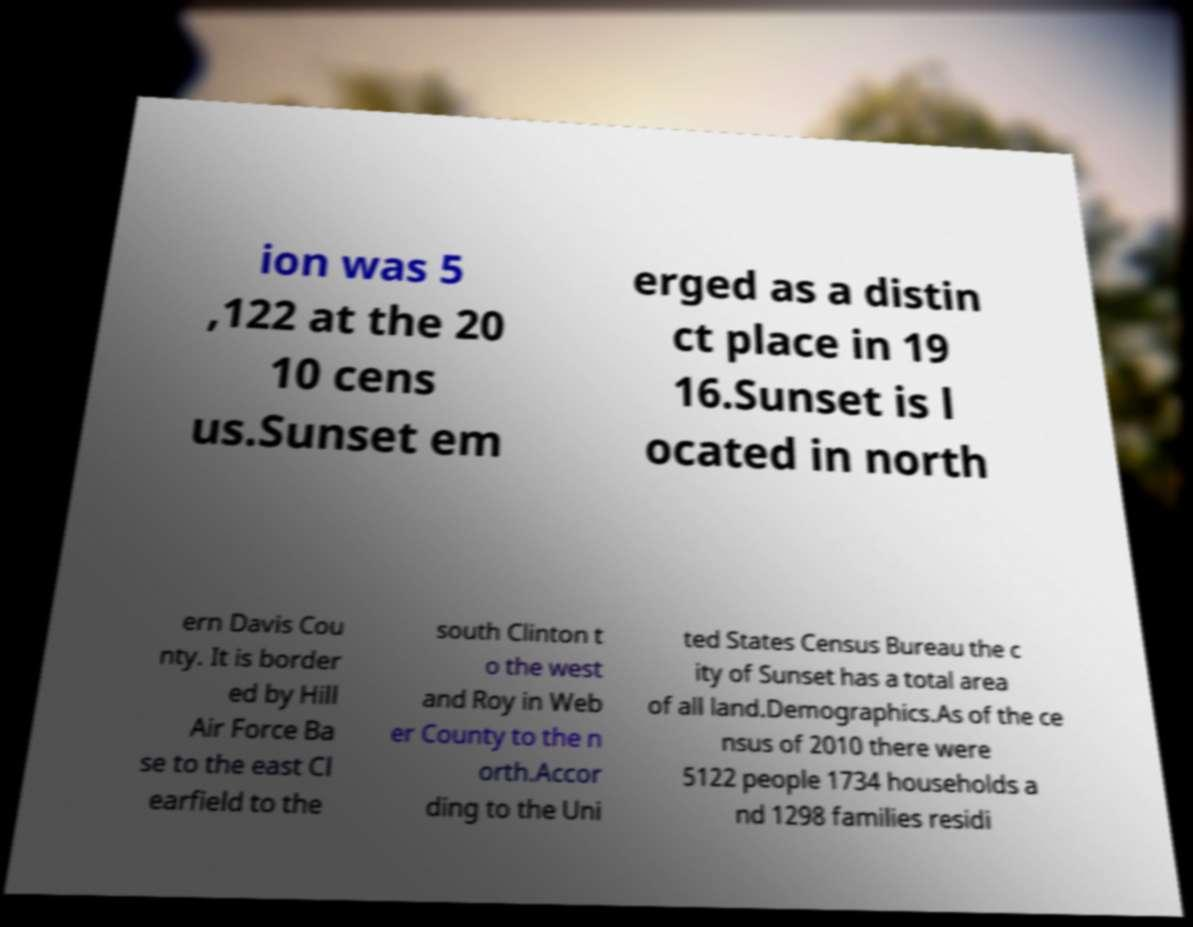What messages or text are displayed in this image? I need them in a readable, typed format. ion was 5 ,122 at the 20 10 cens us.Sunset em erged as a distin ct place in 19 16.Sunset is l ocated in north ern Davis Cou nty. It is border ed by Hill Air Force Ba se to the east Cl earfield to the south Clinton t o the west and Roy in Web er County to the n orth.Accor ding to the Uni ted States Census Bureau the c ity of Sunset has a total area of all land.Demographics.As of the ce nsus of 2010 there were 5122 people 1734 households a nd 1298 families residi 